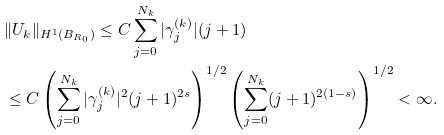Convert formula to latex. <formula><loc_0><loc_0><loc_500><loc_500>& \| U _ { k } \| _ { H ^ { 1 } ( B _ { R _ { 0 } } ) } \leq C \sum _ { j = 0 } ^ { N _ { k } } | \gamma _ { j } ^ { ( k ) } | ( j + 1 ) \\ & \leq C \left ( \sum _ { j = 0 } ^ { N _ { k } } | \gamma _ { j } ^ { ( k ) } | ^ { 2 } ( j + 1 ) ^ { 2 s } \right ) ^ { 1 / 2 } \left ( \sum _ { j = 0 } ^ { N _ { k } } ( j + 1 ) ^ { 2 ( 1 - s ) } \right ) ^ { 1 / 2 } < \infty .</formula> 